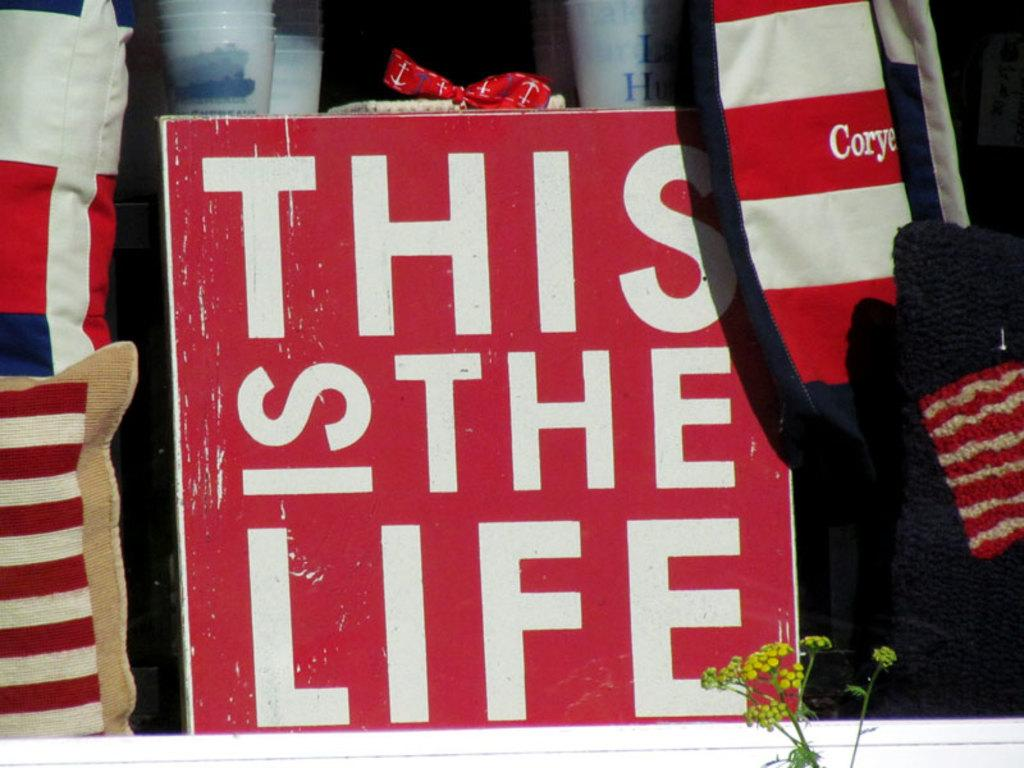What can be observed in the image in terms of objects? There are many objects in the image. Can you describe a specific object with text in the image? There is text on a board in the image. What type of vegetation is present at the bottom of the image? There is a plant at the bottom of the image. Can you see a pan in the image? There is no pan present in the image. 